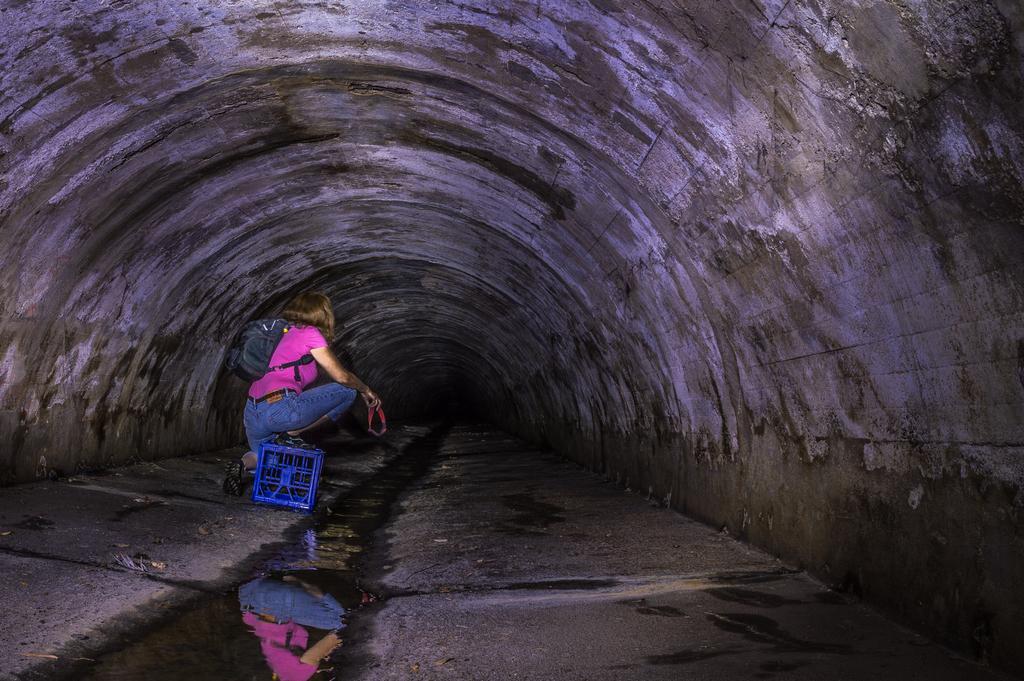How would you summarize this image in a sentence or two? In this image there is a women she is wearing pink T-shirt and blue jeans and a bag, behind her there is a box , she is sitting in a tunnel. 